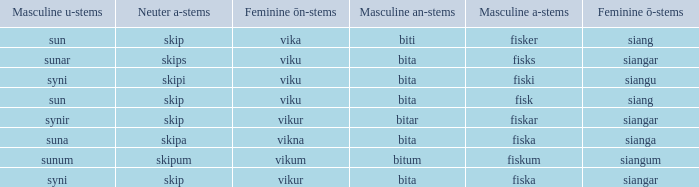What is the u form of the word with a neuter form of skip and a masculine a-ending of fisker? Sun. 